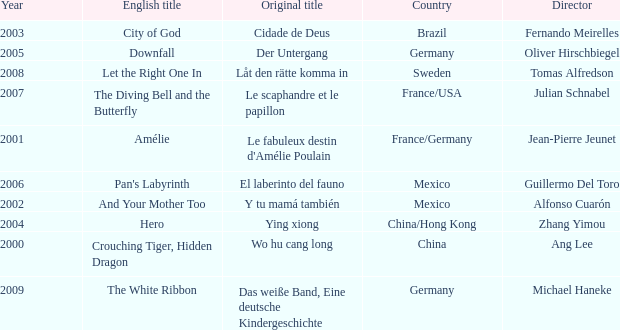Name the title of jean-pierre jeunet Amélie. 